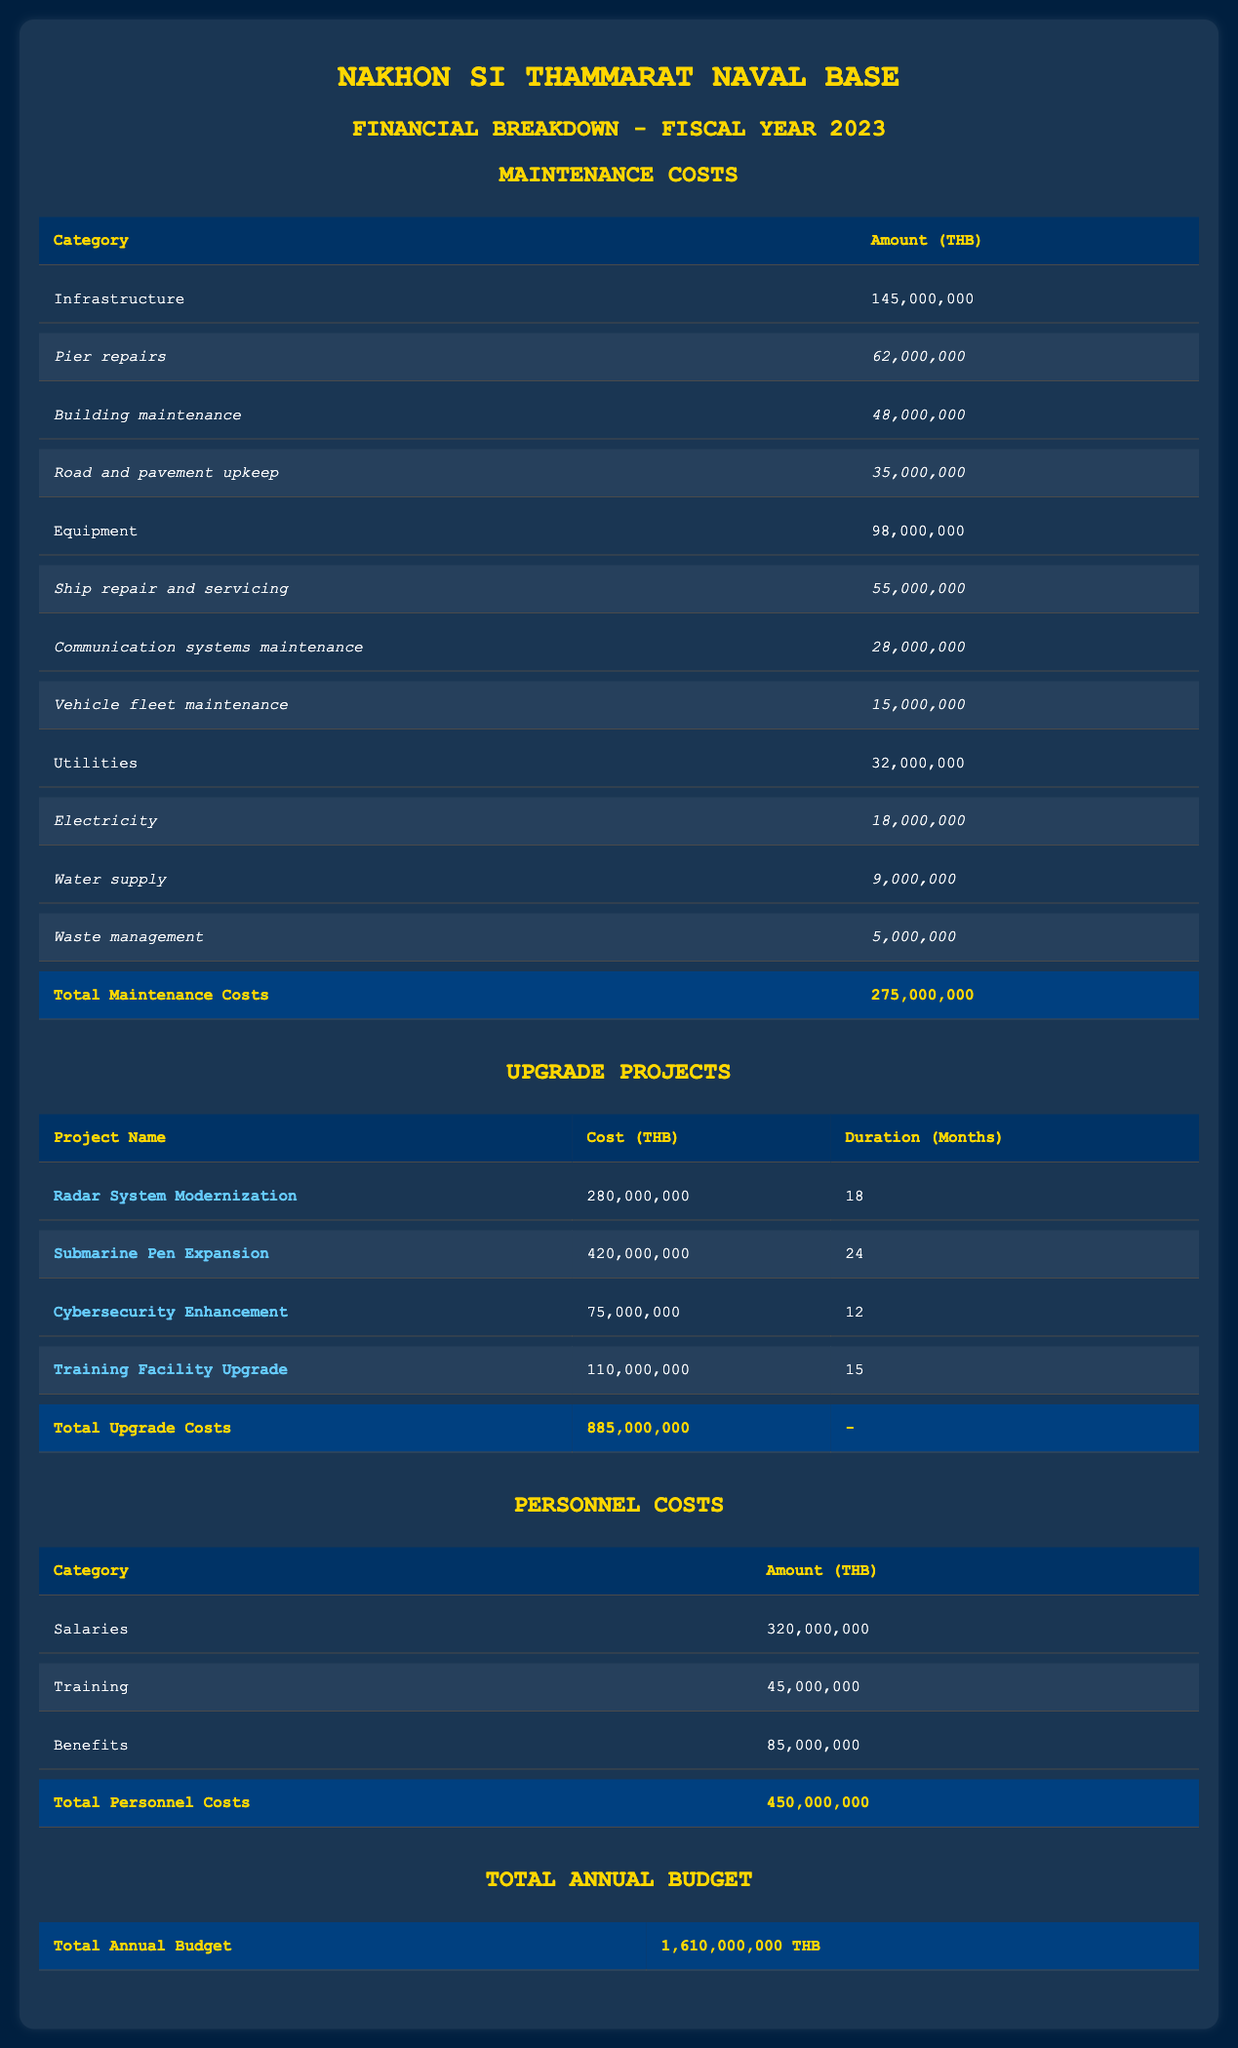What is the total amount allocated for personnel costs? The table shows a specific section for personnel costs, which includes salaries (320 million THB), training (45 million THB), and benefits (85 million THB). Adding these amounts together: 320 + 45 + 85 = 450 million THB.
Answer: 450 million THB What are the maintenance costs for equipment? From the table, the total amount allocated for equipment maintenance is specified directly as 98 million THB.
Answer: 98 million THB Is the cost of the Submarine Pen Expansion greater than the cost of the Radar System Modernization? The cost of the Submarine Pen Expansion is 420 million THB and the Radar System Modernization costs 280 million THB. Since 420 is greater than 280, the statement is true.
Answer: Yes How much is spent on communication systems maintenance within equipment costs? The amount allocated specifically for communication systems maintenance is listed as 28 million THB in the equipment category.
Answer: 28 million THB What is the total cost of the upgrade projects? The table lists four upgrade projects with their individual costs: Radar System Modernization (280 million), Submarine Pen Expansion (420 million), Cybersecurity Enhancement (75 million), and Training Facility Upgrade (110 million). Summing these values: 280 + 420 + 75 + 110 = 885 million THB.
Answer: 885 million THB What percentage of the total annual budget is allocated for maintenance costs? The total annual budget is 1,610 million THB. The total maintenance costs equal 275 million THB. To find the percentage, divide 275 by 1610 and multiply by 100: (275 / 1610) * 100 = 17.05% (approximately 17%).
Answer: Approximately 17% Are the total personnel costs greater than the total maintenance costs? The total personnel costs amount to 450 million THB, while the total maintenance costs are 275 million THB. Since 450 is greater than 275, the statement is true.
Answer: Yes What is the duration of the Cybersecurity Enhancement upgrade project? The duration for the Cybersecurity Enhancement project is indicated as 12 months in the upgrade projects table.
Answer: 12 months How much more is spent on submarine pen expansion compared to cybersecurity enhancement? The cost of Submarine Pen Expansion is 420 million THB, while the cost of Cybersecurity Enhancement is 75 million THB. To find the difference, subtract the latter from the former: 420 - 75 = 345 million THB.
Answer: 345 million THB 